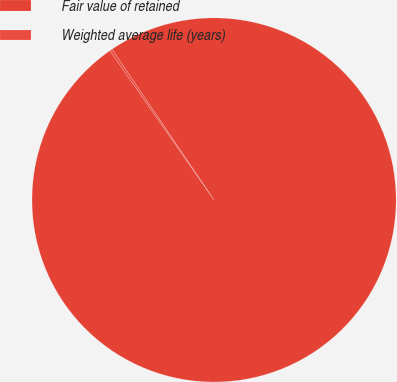Convert chart. <chart><loc_0><loc_0><loc_500><loc_500><pie_chart><fcel>Fair value of retained<fcel>Weighted average life (years)<nl><fcel>99.77%<fcel>0.23%<nl></chart> 